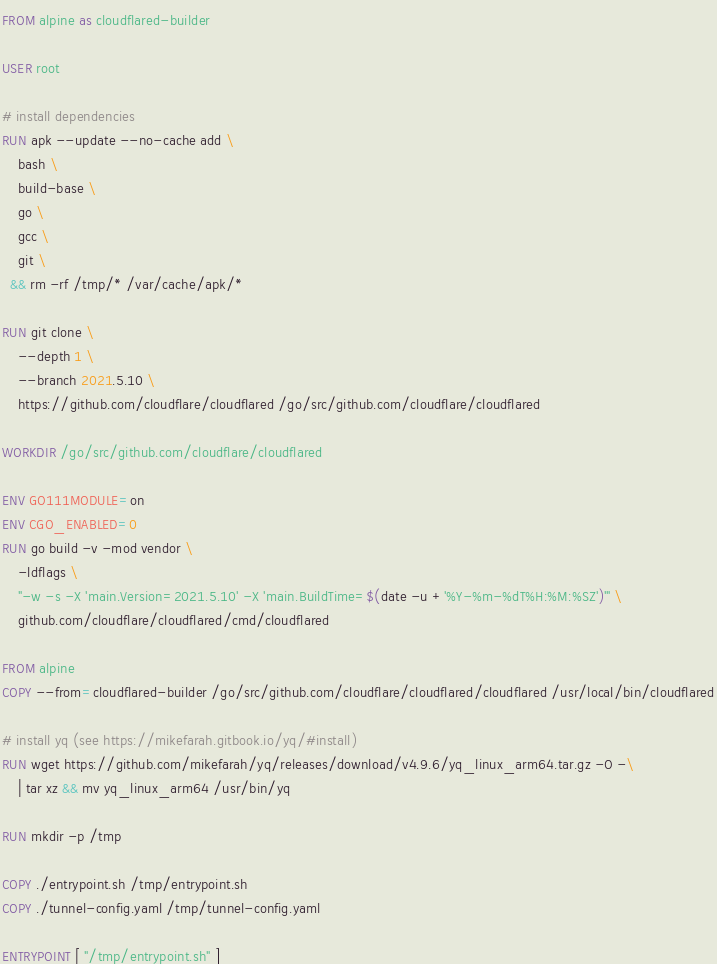Convert code to text. <code><loc_0><loc_0><loc_500><loc_500><_Dockerfile_>FROM alpine as cloudflared-builder

USER root

# install dependencies
RUN apk --update --no-cache add \
    bash \
    build-base \
    go \
    gcc \
    git \
  && rm -rf /tmp/* /var/cache/apk/*

RUN git clone \
    --depth 1 \
    --branch 2021.5.10 \
    https://github.com/cloudflare/cloudflared /go/src/github.com/cloudflare/cloudflared

WORKDIR /go/src/github.com/cloudflare/cloudflared

ENV GO111MODULE=on
ENV CGO_ENABLED=0
RUN go build -v -mod vendor \
    -ldflags \
    "-w -s -X 'main.Version=2021.5.10' -X 'main.BuildTime=$(date -u +'%Y-%m-%dT%H:%M:%SZ')'" \
    github.com/cloudflare/cloudflared/cmd/cloudflared

FROM alpine
COPY --from=cloudflared-builder /go/src/github.com/cloudflare/cloudflared/cloudflared /usr/local/bin/cloudflared

# install yq (see https://mikefarah.gitbook.io/yq/#install)
RUN wget https://github.com/mikefarah/yq/releases/download/v4.9.6/yq_linux_arm64.tar.gz -O -\
    | tar xz && mv yq_linux_arm64 /usr/bin/yq

RUN mkdir -p /tmp

COPY ./entrypoint.sh /tmp/entrypoint.sh
COPY ./tunnel-config.yaml /tmp/tunnel-config.yaml

ENTRYPOINT [ "/tmp/entrypoint.sh" ]
</code> 